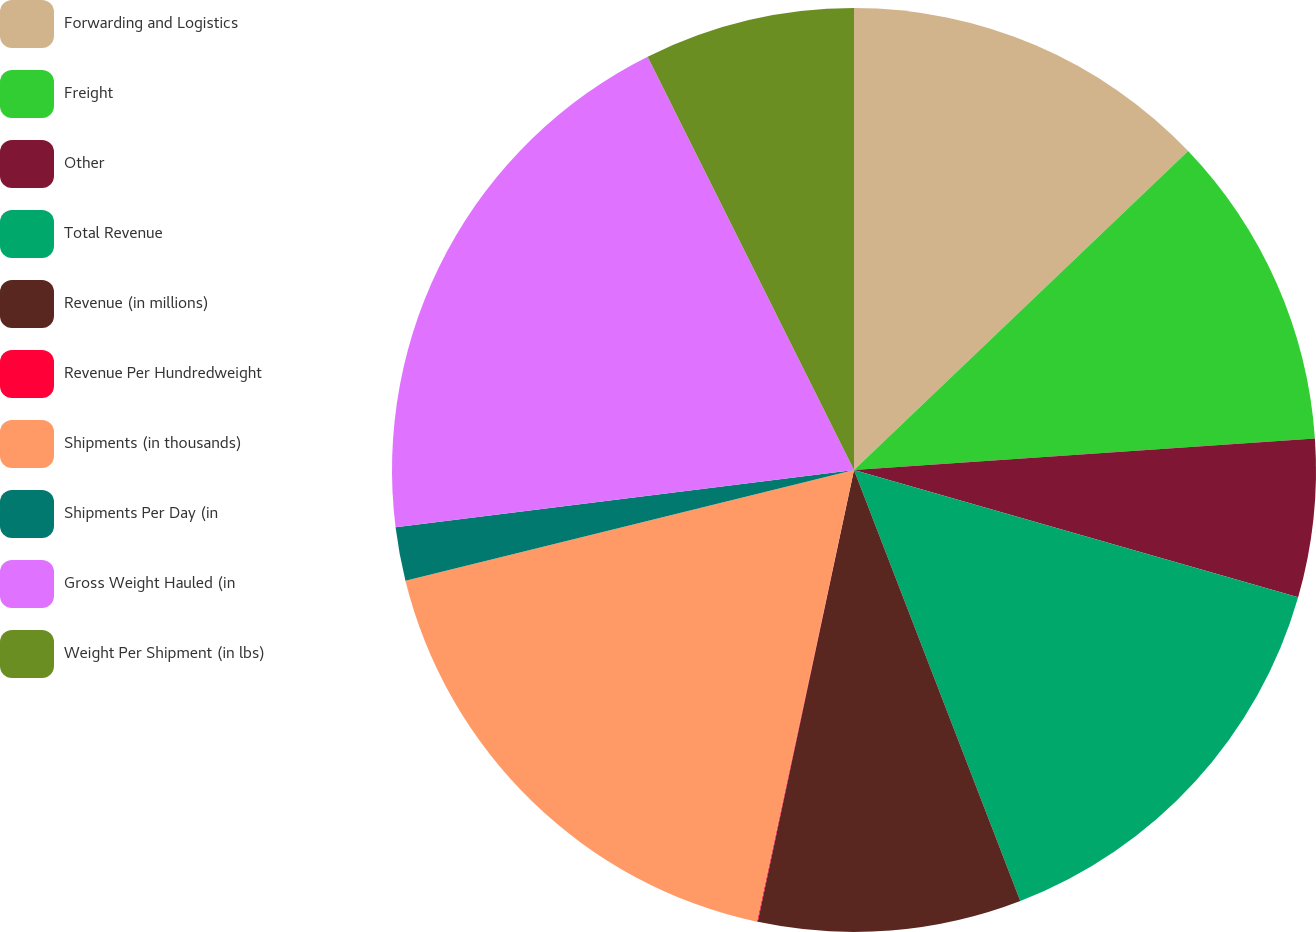Convert chart to OTSL. <chart><loc_0><loc_0><loc_500><loc_500><pie_chart><fcel>Forwarding and Logistics<fcel>Freight<fcel>Other<fcel>Total Revenue<fcel>Revenue (in millions)<fcel>Revenue Per Hundredweight<fcel>Shipments (in thousands)<fcel>Shipments Per Day (in<fcel>Gross Weight Hauled (in<fcel>Weight Per Shipment (in lbs)<nl><fcel>12.87%<fcel>11.04%<fcel>5.53%<fcel>14.7%<fcel>9.2%<fcel>0.03%<fcel>17.78%<fcel>1.87%<fcel>19.61%<fcel>7.37%<nl></chart> 